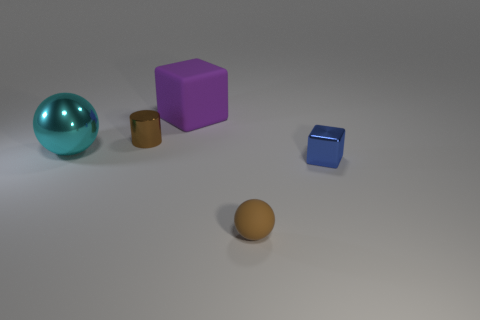Is the number of tiny things that are to the left of the large sphere the same as the number of big red objects?
Ensure brevity in your answer.  Yes. There is a tiny shiny object that is to the left of the small rubber thing; does it have the same color as the sphere on the right side of the rubber cube?
Give a very brief answer. Yes. How many objects are in front of the big cyan shiny ball and behind the brown sphere?
Your response must be concise. 1. What number of other things are the same shape as the brown shiny object?
Offer a very short reply. 0. Are there more tiny brown cylinders that are right of the metallic ball than tiny matte blocks?
Give a very brief answer. Yes. The ball that is on the right side of the purple matte block is what color?
Make the answer very short. Brown. What size is the metallic object that is the same color as the tiny matte object?
Offer a terse response. Small. What number of rubber objects are either small blocks or small red objects?
Keep it short and to the point. 0. There is a object to the left of the tiny object behind the metal ball; are there any cyan shiny objects that are on the right side of it?
Ensure brevity in your answer.  No. There is a tiny shiny block; how many tiny metallic things are right of it?
Your answer should be compact. 0. 